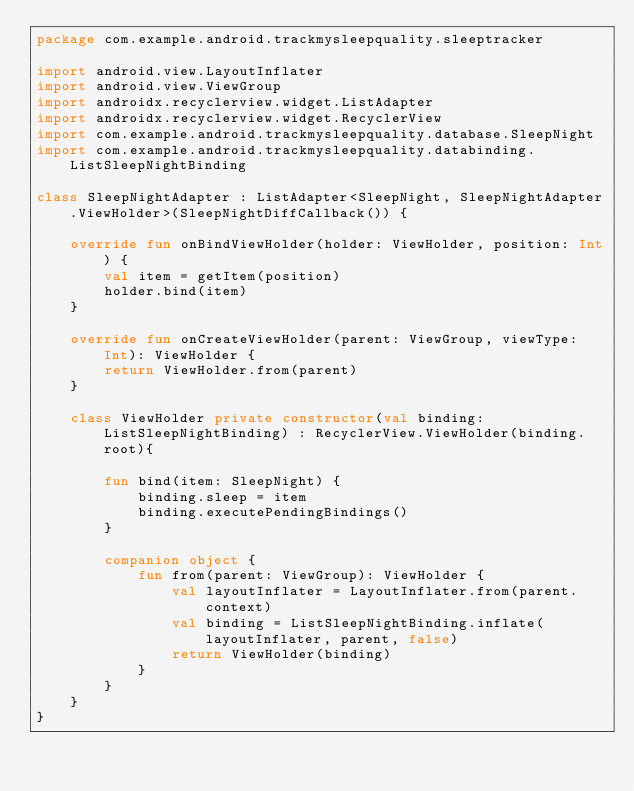<code> <loc_0><loc_0><loc_500><loc_500><_Kotlin_>package com.example.android.trackmysleepquality.sleeptracker

import android.view.LayoutInflater
import android.view.ViewGroup
import androidx.recyclerview.widget.ListAdapter
import androidx.recyclerview.widget.RecyclerView
import com.example.android.trackmysleepquality.database.SleepNight
import com.example.android.trackmysleepquality.databinding.ListSleepNightBinding

class SleepNightAdapter : ListAdapter<SleepNight, SleepNightAdapter.ViewHolder>(SleepNightDiffCallback()) {

    override fun onBindViewHolder(holder: ViewHolder, position: Int) {
        val item = getItem(position)
        holder.bind(item)
    }

    override fun onCreateViewHolder(parent: ViewGroup, viewType: Int): ViewHolder {
        return ViewHolder.from(parent)
    }

    class ViewHolder private constructor(val binding: ListSleepNightBinding) : RecyclerView.ViewHolder(binding.root){

        fun bind(item: SleepNight) {
            binding.sleep = item
            binding.executePendingBindings()
        }

        companion object {
            fun from(parent: ViewGroup): ViewHolder {
                val layoutInflater = LayoutInflater.from(parent.context)
                val binding = ListSleepNightBinding.inflate(layoutInflater, parent, false)
                return ViewHolder(binding)
            }
        }
    }
}</code> 